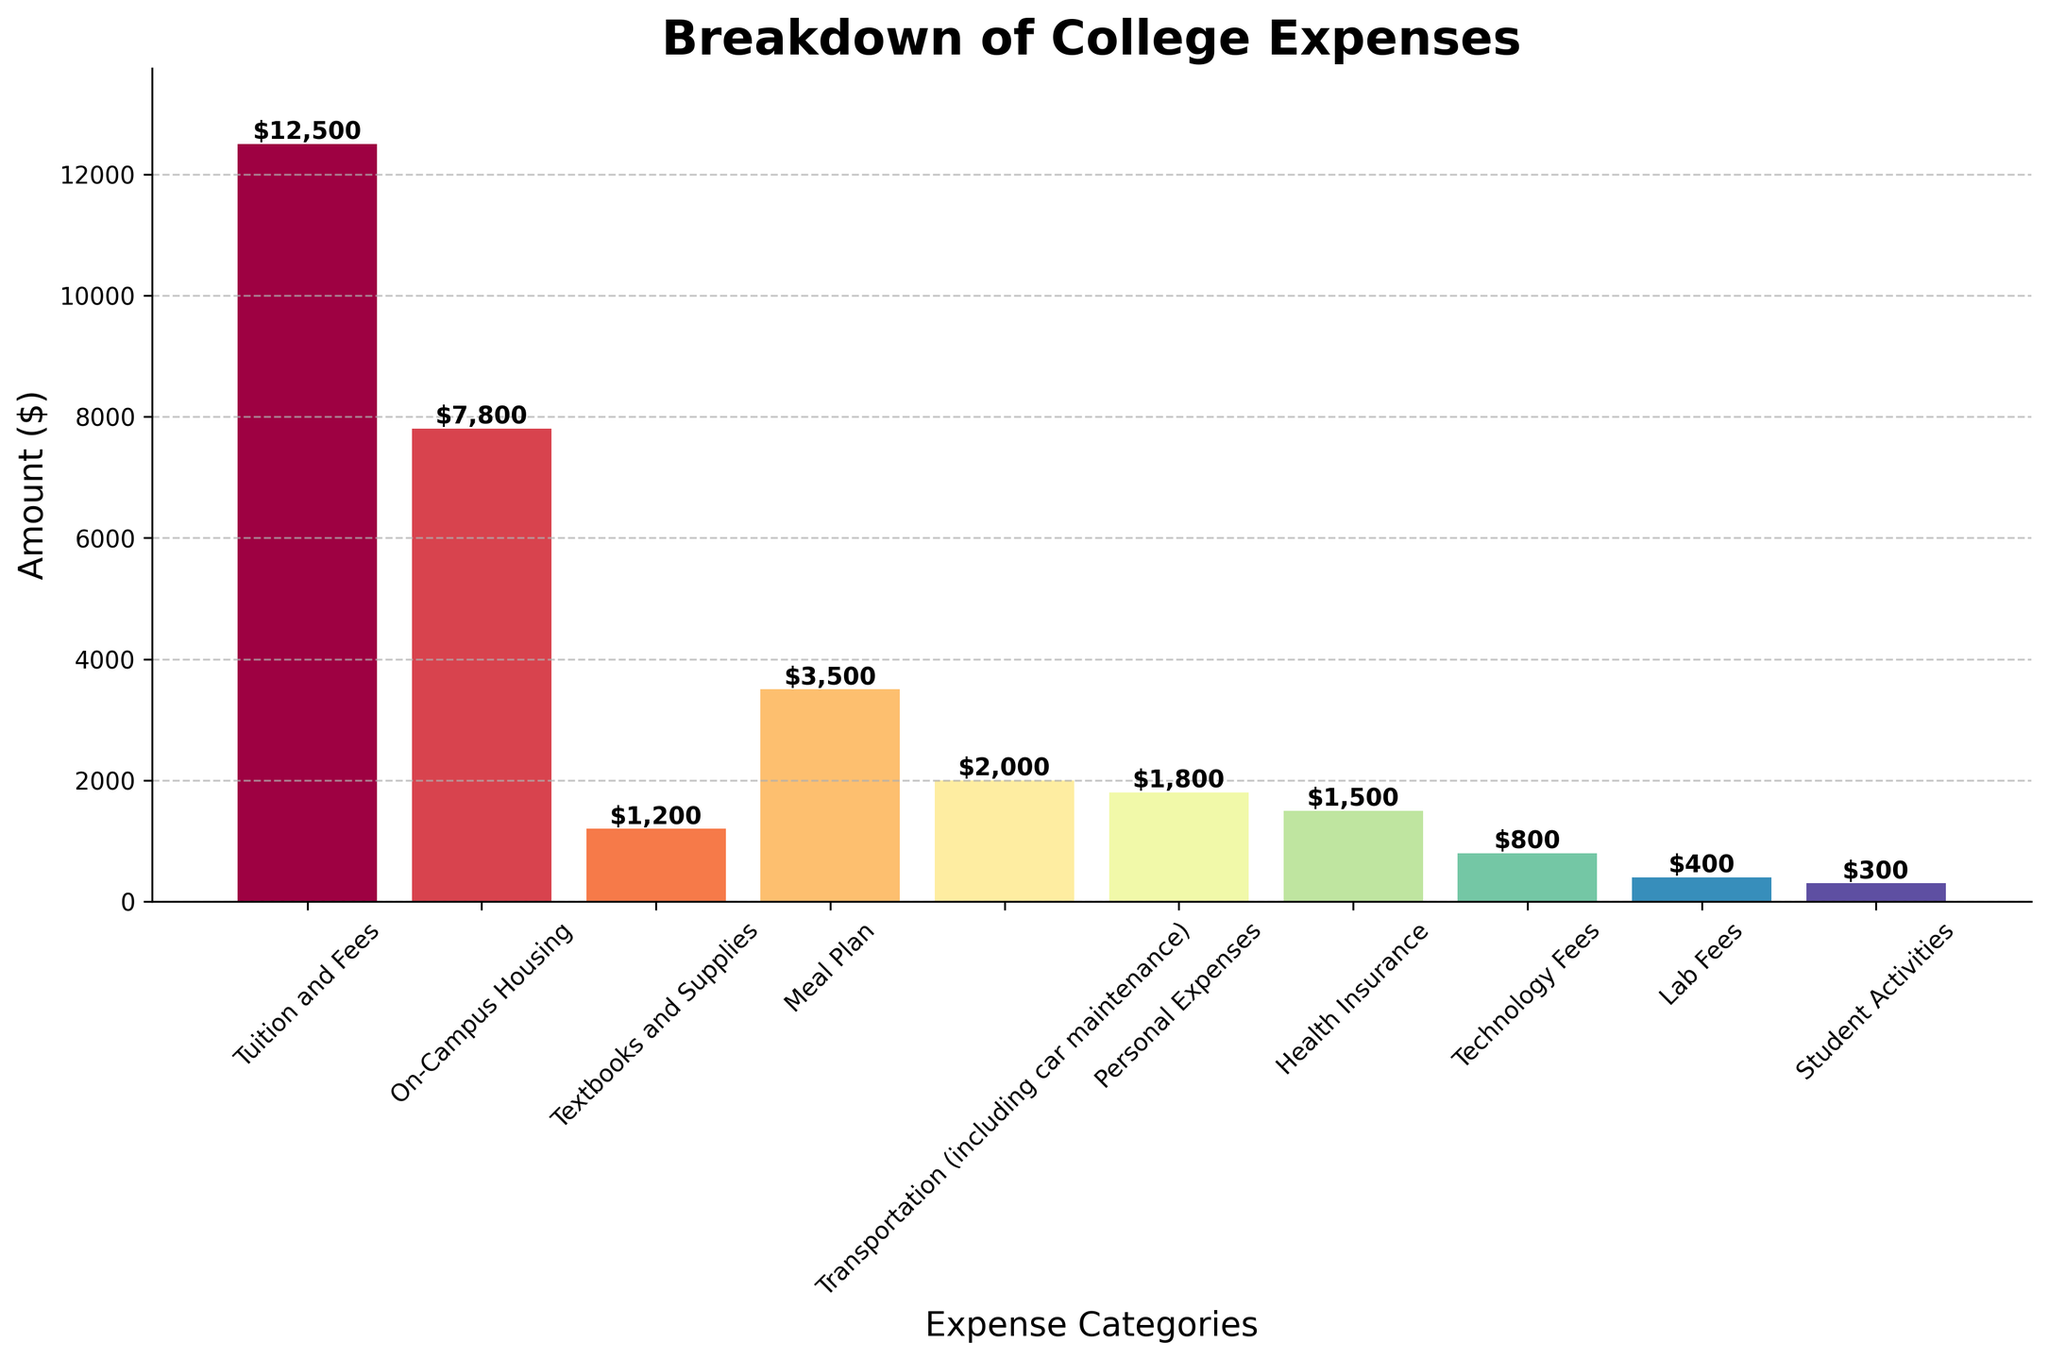What's the most expensive category? The bar for "Tuition and Fees" is the tallest among all the bars which indicates that it has the highest expense.
Answer: Tuition and Fees What's the total expense for non-tuition categories? Add the expenses for all categories except "Tuition and Fees": 7800 + 1200 + 3500 + 2000 + 1800 + 1500 + 800 + 400 + 300 = 19300
Answer: 19300 How much more expensive is "On-Campus Housing" compared to "Meal Plan"? Subtract the expense for "Meal Plan" from "On-Campus Housing": 7800 - 3500 = 4300
Answer: 4300 Which category has the least expense? The bar for "Student Activities" is the shortest among all the bars which indicates that it has the lowest expense.
Answer: Student Activities What is the combined expense of "Health Insurance" and "Technology Fees"? Add the expenses for "Health Insurance" and "Technology Fees": 1500 + 800 = 2300
Answer: 2300 Is "Transportation" more expensive than "Personal Expenses"? Compare the bar heights for "Transportation" and "Personal Expenses"; the "Transportation" bar is slightly taller.
Answer: Yes Calculate the average expense across all categories. Sum all the expenses and divide by the number of categories: (12500 + 7800 + 1200 + 3500 + 2000 + 1800 + 1500 + 800 + 400 + 300) / 10 = 31200 / 10 = 3120
Answer: 3120 Which categories have expenses below $1000? Identify bars with heights less than $1000. Both "Lab Fees" ($400) and "Student Activities" ($300) fall below this threshold.
Answer: Lab Fees and Student Activities What is the difference in expense between "Textbooks and Supplies" and "Meal Plan"? Subtract the expense for "Textbooks and Supplies" from "Meal Plan": 3500 - 1200 = 2300
Answer: 2300 How many categories have expenses greater than or equal to $2000? Count the bars with heights greater than or equal to $2000: "Tuition and Fees", "On-Campus Housing", "Meal Plan", and "Transportation" make a total of 4 categories.
Answer: 4 